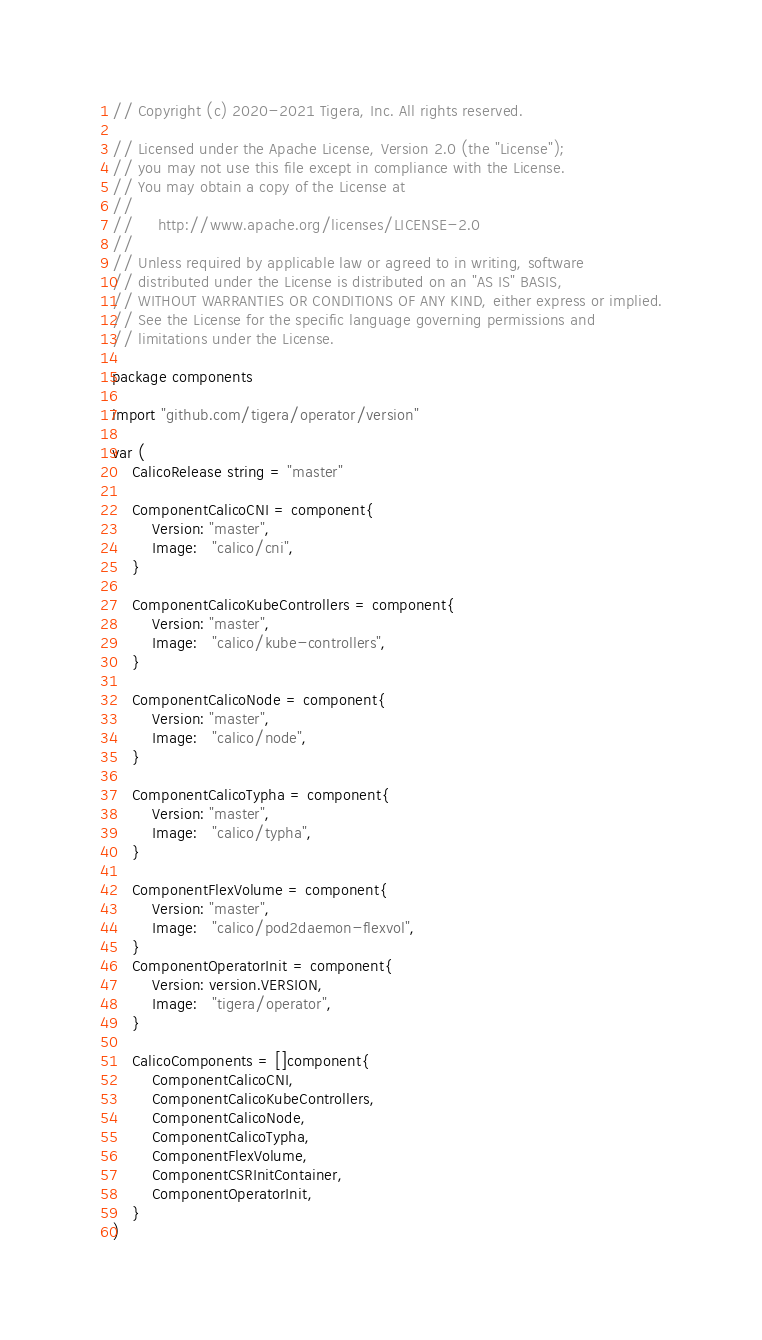<code> <loc_0><loc_0><loc_500><loc_500><_Go_>// Copyright (c) 2020-2021 Tigera, Inc. All rights reserved.

// Licensed under the Apache License, Version 2.0 (the "License");
// you may not use this file except in compliance with the License.
// You may obtain a copy of the License at
//
//     http://www.apache.org/licenses/LICENSE-2.0
//
// Unless required by applicable law or agreed to in writing, software
// distributed under the License is distributed on an "AS IS" BASIS,
// WITHOUT WARRANTIES OR CONDITIONS OF ANY KIND, either express or implied.
// See the License for the specific language governing permissions and
// limitations under the License.

package components

import "github.com/tigera/operator/version"

var (
	CalicoRelease string = "master"

	ComponentCalicoCNI = component{
		Version: "master",
		Image:   "calico/cni",
	}

	ComponentCalicoKubeControllers = component{
		Version: "master",
		Image:   "calico/kube-controllers",
	}

	ComponentCalicoNode = component{
		Version: "master",
		Image:   "calico/node",
	}

	ComponentCalicoTypha = component{
		Version: "master",
		Image:   "calico/typha",
	}

	ComponentFlexVolume = component{
		Version: "master",
		Image:   "calico/pod2daemon-flexvol",
	}
	ComponentOperatorInit = component{
		Version: version.VERSION,
		Image:   "tigera/operator",
	}

	CalicoComponents = []component{
		ComponentCalicoCNI,
		ComponentCalicoKubeControllers,
		ComponentCalicoNode,
		ComponentCalicoTypha,
		ComponentFlexVolume,
		ComponentCSRInitContainer,
		ComponentOperatorInit,
	}
)
</code> 